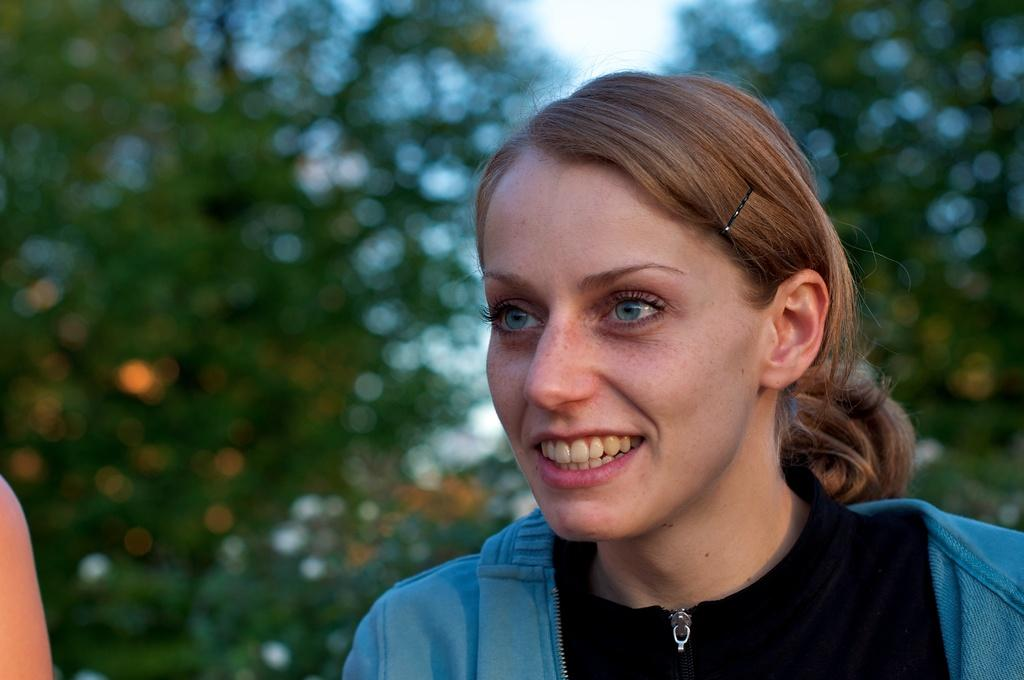What is the main subject of the image? There is a woman standing in the image. What is the woman wearing on her upper body? The woman is wearing a black shirt and a blue coat. What can be seen in the background of the image? There are trees in the background of the image. How is the background of the image depicted? The background of the image is blurred. What type of vacation is the woman planning based on the image? There is no information about a vacation in the image, so it cannot be determined. How is the distribution of the trees in the background of the image? The distribution of the trees in the background cannot be determined from the image, as it only shows a general view of the trees. 